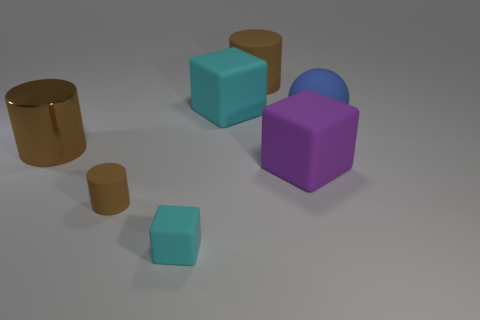There is a cyan thing that is the same material as the big cyan cube; what is its size? The cyan object that shares the same material characteristics as the larger cyan cube is smaller in size. To provide more context, it is significantly less voluminous compared to the other objects in the image, particularly the larger cubes and cylinders present. 